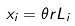<formula> <loc_0><loc_0><loc_500><loc_500>x _ { i } = \theta r L _ { i }</formula> 